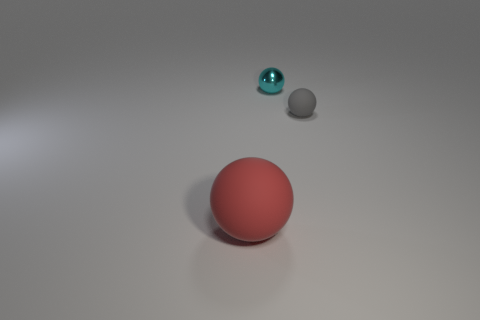Subtract all big rubber spheres. How many spheres are left? 2 Add 2 shiny objects. How many objects exist? 5 Subtract all cyan balls. How many balls are left? 2 Subtract 1 balls. How many balls are left? 2 Add 3 large red rubber spheres. How many large red rubber spheres exist? 4 Subtract 0 red cylinders. How many objects are left? 3 Subtract all brown spheres. Subtract all green blocks. How many spheres are left? 3 Subtract all tiny purple shiny things. Subtract all red things. How many objects are left? 2 Add 2 matte things. How many matte things are left? 4 